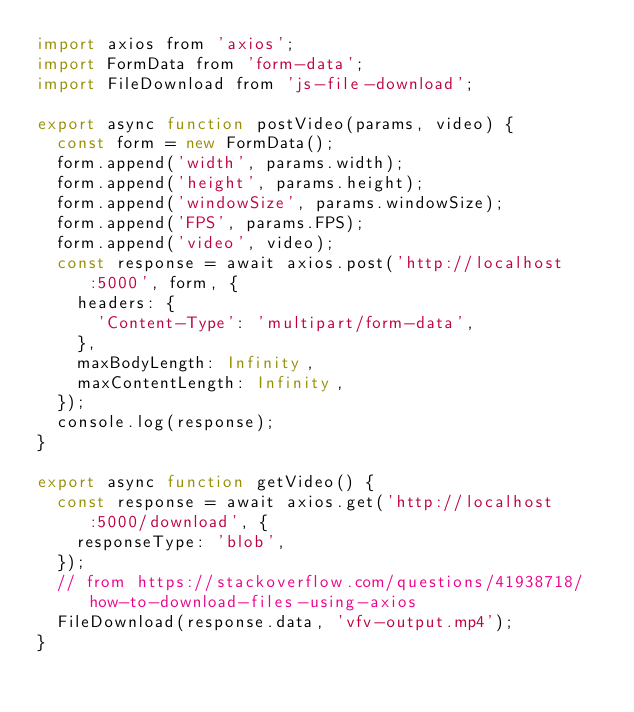Convert code to text. <code><loc_0><loc_0><loc_500><loc_500><_JavaScript_>import axios from 'axios';
import FormData from 'form-data';
import FileDownload from 'js-file-download';

export async function postVideo(params, video) {
  const form = new FormData();
  form.append('width', params.width);
  form.append('height', params.height);
  form.append('windowSize', params.windowSize);
  form.append('FPS', params.FPS);
  form.append('video', video);
  const response = await axios.post('http://localhost:5000', form, {
    headers: {
      'Content-Type': 'multipart/form-data',
    },
    maxBodyLength: Infinity,
    maxContentLength: Infinity,
  });
  console.log(response);
}

export async function getVideo() {
  const response = await axios.get('http://localhost:5000/download', {
    responseType: 'blob',
  });
  // from https://stackoverflow.com/questions/41938718/how-to-download-files-using-axios
  FileDownload(response.data, 'vfv-output.mp4');
}
</code> 